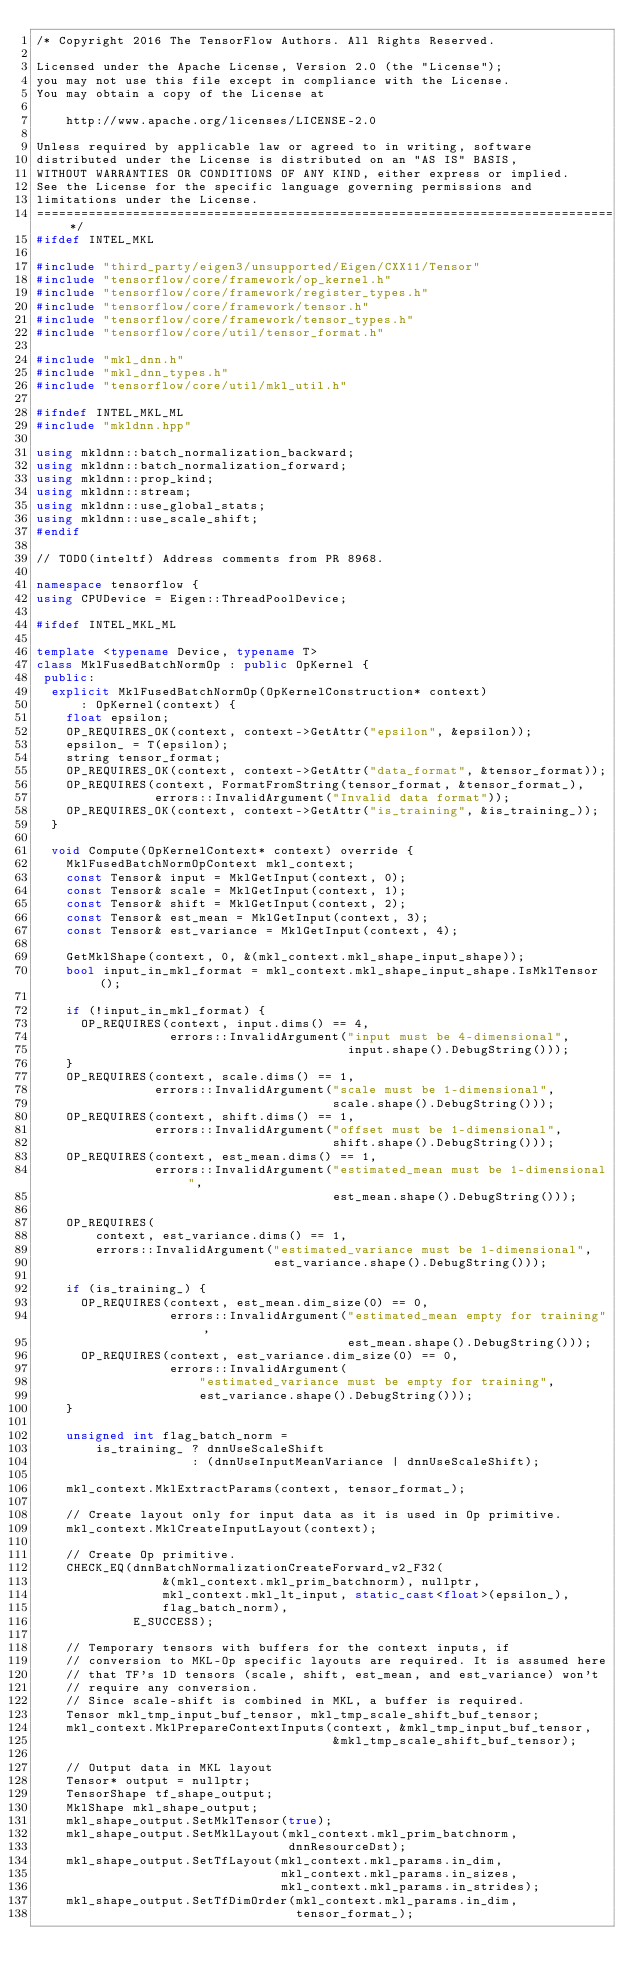<code> <loc_0><loc_0><loc_500><loc_500><_C++_>/* Copyright 2016 The TensorFlow Authors. All Rights Reserved.

Licensed under the Apache License, Version 2.0 (the "License");
you may not use this file except in compliance with the License.
You may obtain a copy of the License at

    http://www.apache.org/licenses/LICENSE-2.0

Unless required by applicable law or agreed to in writing, software
distributed under the License is distributed on an "AS IS" BASIS,
WITHOUT WARRANTIES OR CONDITIONS OF ANY KIND, either express or implied.
See the License for the specific language governing permissions and
limitations under the License.
==============================================================================*/
#ifdef INTEL_MKL

#include "third_party/eigen3/unsupported/Eigen/CXX11/Tensor"
#include "tensorflow/core/framework/op_kernel.h"
#include "tensorflow/core/framework/register_types.h"
#include "tensorflow/core/framework/tensor.h"
#include "tensorflow/core/framework/tensor_types.h"
#include "tensorflow/core/util/tensor_format.h"

#include "mkl_dnn.h"
#include "mkl_dnn_types.h"
#include "tensorflow/core/util/mkl_util.h"

#ifndef INTEL_MKL_ML
#include "mkldnn.hpp"

using mkldnn::batch_normalization_backward;
using mkldnn::batch_normalization_forward;
using mkldnn::prop_kind;
using mkldnn::stream;
using mkldnn::use_global_stats;
using mkldnn::use_scale_shift;
#endif

// TODO(inteltf) Address comments from PR 8968.

namespace tensorflow {
using CPUDevice = Eigen::ThreadPoolDevice;

#ifdef INTEL_MKL_ML

template <typename Device, typename T>
class MklFusedBatchNormOp : public OpKernel {
 public:
  explicit MklFusedBatchNormOp(OpKernelConstruction* context)
      : OpKernel(context) {
    float epsilon;
    OP_REQUIRES_OK(context, context->GetAttr("epsilon", &epsilon));
    epsilon_ = T(epsilon);
    string tensor_format;
    OP_REQUIRES_OK(context, context->GetAttr("data_format", &tensor_format));
    OP_REQUIRES(context, FormatFromString(tensor_format, &tensor_format_),
                errors::InvalidArgument("Invalid data format"));
    OP_REQUIRES_OK(context, context->GetAttr("is_training", &is_training_));
  }

  void Compute(OpKernelContext* context) override {
    MklFusedBatchNormOpContext mkl_context;
    const Tensor& input = MklGetInput(context, 0);
    const Tensor& scale = MklGetInput(context, 1);
    const Tensor& shift = MklGetInput(context, 2);
    const Tensor& est_mean = MklGetInput(context, 3);
    const Tensor& est_variance = MklGetInput(context, 4);

    GetMklShape(context, 0, &(mkl_context.mkl_shape_input_shape));
    bool input_in_mkl_format = mkl_context.mkl_shape_input_shape.IsMklTensor();

    if (!input_in_mkl_format) {
      OP_REQUIRES(context, input.dims() == 4,
                  errors::InvalidArgument("input must be 4-dimensional",
                                          input.shape().DebugString()));
    }
    OP_REQUIRES(context, scale.dims() == 1,
                errors::InvalidArgument("scale must be 1-dimensional",
                                        scale.shape().DebugString()));
    OP_REQUIRES(context, shift.dims() == 1,
                errors::InvalidArgument("offset must be 1-dimensional",
                                        shift.shape().DebugString()));
    OP_REQUIRES(context, est_mean.dims() == 1,
                errors::InvalidArgument("estimated_mean must be 1-dimensional",
                                        est_mean.shape().DebugString()));

    OP_REQUIRES(
        context, est_variance.dims() == 1,
        errors::InvalidArgument("estimated_variance must be 1-dimensional",
                                est_variance.shape().DebugString()));

    if (is_training_) {
      OP_REQUIRES(context, est_mean.dim_size(0) == 0,
                  errors::InvalidArgument("estimated_mean empty for training",
                                          est_mean.shape().DebugString()));
      OP_REQUIRES(context, est_variance.dim_size(0) == 0,
                  errors::InvalidArgument(
                      "estimated_variance must be empty for training",
                      est_variance.shape().DebugString()));
    }

    unsigned int flag_batch_norm =
        is_training_ ? dnnUseScaleShift
                     : (dnnUseInputMeanVariance | dnnUseScaleShift);

    mkl_context.MklExtractParams(context, tensor_format_);

    // Create layout only for input data as it is used in Op primitive.
    mkl_context.MklCreateInputLayout(context);

    // Create Op primitive.
    CHECK_EQ(dnnBatchNormalizationCreateForward_v2_F32(
                 &(mkl_context.mkl_prim_batchnorm), nullptr,
                 mkl_context.mkl_lt_input, static_cast<float>(epsilon_),
                 flag_batch_norm),
             E_SUCCESS);

    // Temporary tensors with buffers for the context inputs, if
    // conversion to MKL-Op specific layouts are required. It is assumed here
    // that TF's 1D tensors (scale, shift, est_mean, and est_variance) won't
    // require any conversion.
    // Since scale-shift is combined in MKL, a buffer is required.
    Tensor mkl_tmp_input_buf_tensor, mkl_tmp_scale_shift_buf_tensor;
    mkl_context.MklPrepareContextInputs(context, &mkl_tmp_input_buf_tensor,
                                        &mkl_tmp_scale_shift_buf_tensor);

    // Output data in MKL layout
    Tensor* output = nullptr;
    TensorShape tf_shape_output;
    MklShape mkl_shape_output;
    mkl_shape_output.SetMklTensor(true);
    mkl_shape_output.SetMklLayout(mkl_context.mkl_prim_batchnorm,
                                  dnnResourceDst);
    mkl_shape_output.SetTfLayout(mkl_context.mkl_params.in_dim,
                                 mkl_context.mkl_params.in_sizes,
                                 mkl_context.mkl_params.in_strides);
    mkl_shape_output.SetTfDimOrder(mkl_context.mkl_params.in_dim,
                                   tensor_format_);</code> 